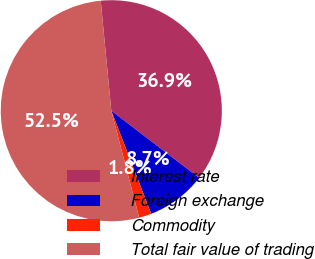<chart> <loc_0><loc_0><loc_500><loc_500><pie_chart><fcel>Interest rate<fcel>Foreign exchange<fcel>Commodity<fcel>Total fair value of trading<nl><fcel>36.92%<fcel>8.72%<fcel>1.82%<fcel>52.53%<nl></chart> 